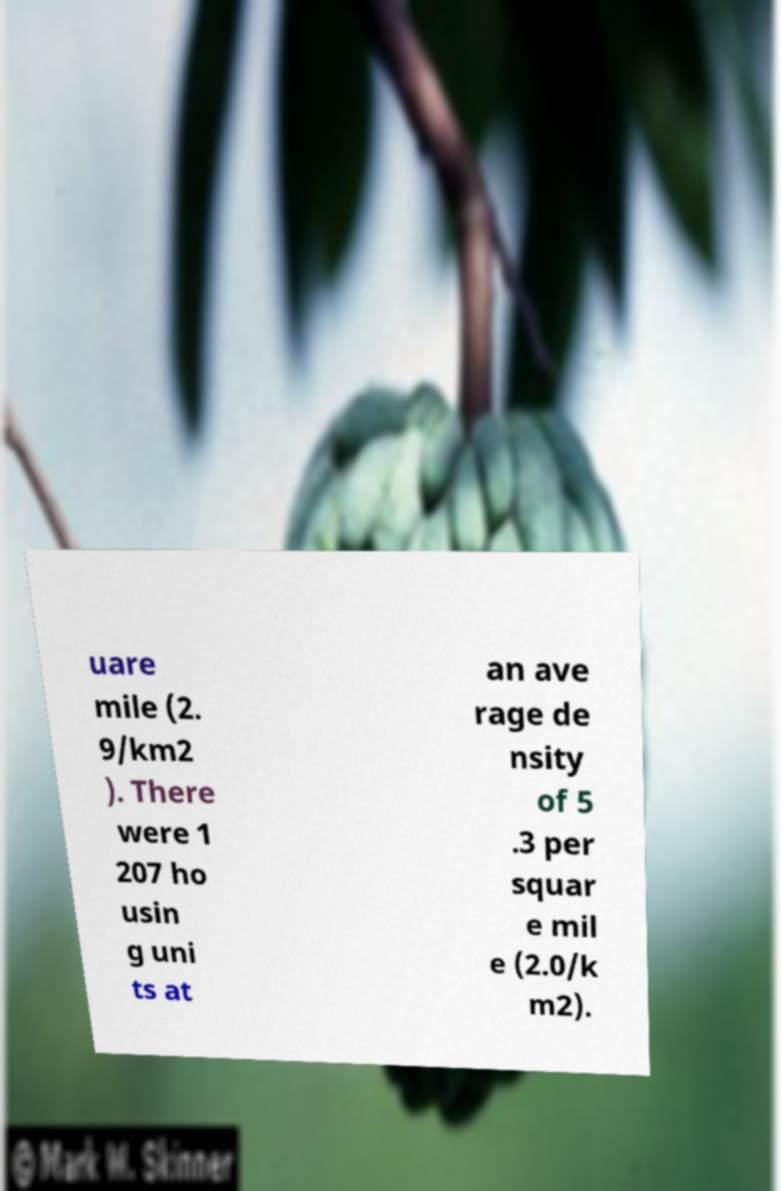I need the written content from this picture converted into text. Can you do that? uare mile (2. 9/km2 ). There were 1 207 ho usin g uni ts at an ave rage de nsity of 5 .3 per squar e mil e (2.0/k m2). 